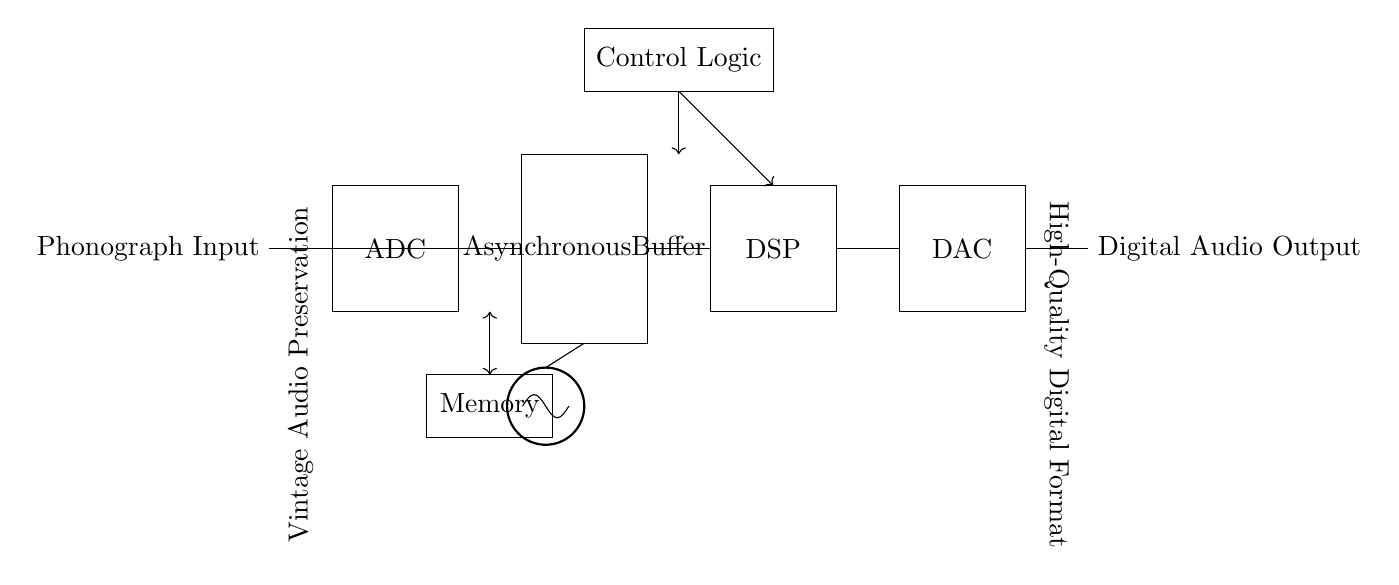What is the input source of this circuit? The input source is labeled as "Phonograph Input," which indicates where the audio signal originates.
Answer: Phonograph Input What type of digital component is used for signal conversion? The circuit includes an "ADC" (Analog-to-Digital Converter) which converts analog audio signals to digital format.
Answer: ADC How many main stages are in this circuit? The circuit has three main stages: ADC, DSP, and DAC, which are crucial for processing the audio signal from input to output.
Answer: Three What is the purpose of the asynchronous buffer in this circuit? The asynchronous buffer temporarily stores audio data to manage differences in processing speed between the ADC and DSP stages, ensuring smooth data flow.
Answer: Data management Which component generates the clock signal? The component labeled "CLK" serves as the oscillator that generates the clock signal necessary for synchronizing the data processing in the circuit.
Answer: CLK What does DSP stand for in this context? DSP stands for "Digital Signal Processing," which refers to the processing of the digital audio data to enhance or manipulate the sound.
Answer: Digital Signal Processing What does the control logic block do? The control logic manages the timing and operation of the different components in the circuit, coordinating data flow between stages like the ADC, buffer, and DSP.
Answer: Coordination 